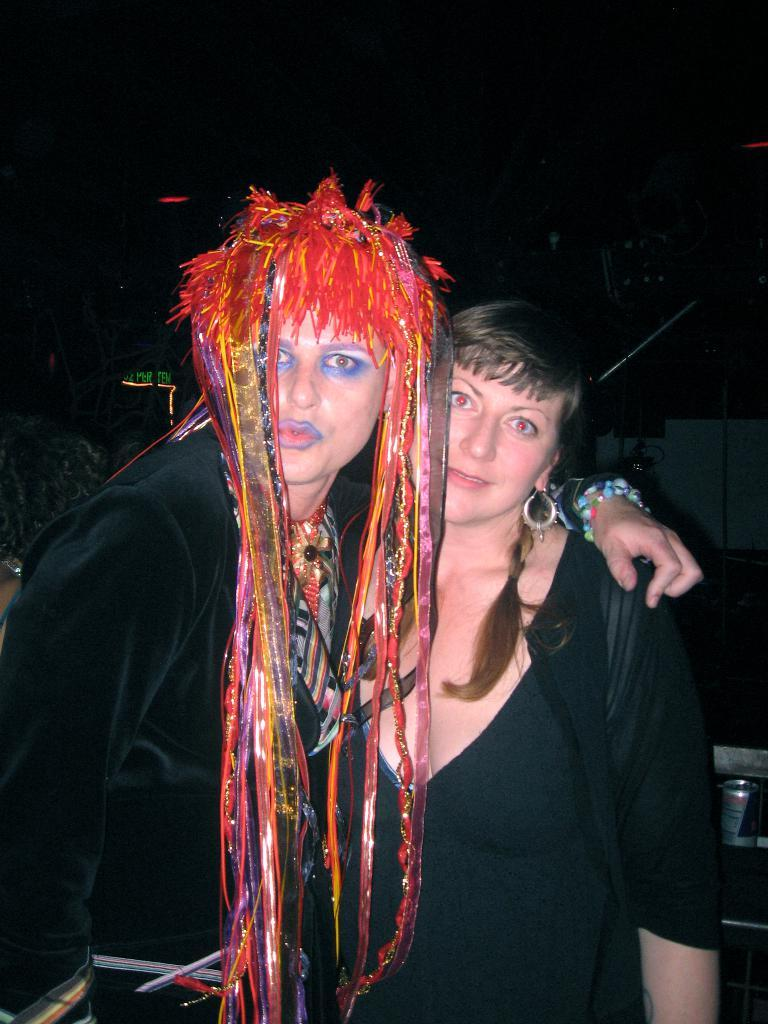How many people are present in the image? There are two people standing in the image. What is the appearance of one person's hair? One person has red decorated hair. What type of object can be seen in the image? There is a coke tin in the image. What is a feature of the background in the image? There is a wall in the image. What is on a surface in the image? There are objects on a surface in the image. How many dogs are visible in the image? There are no dogs present in the image. What type of woman is playing basketball in the image? There is no woman playing basketball in the image. 